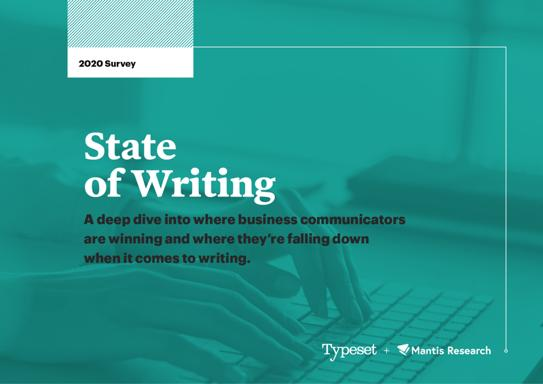Who conducted the research mentioned in the image? The research highlighted in the survey was conducted by Typeset in collaboration with Mantis Research. Together, they aimed to gather actionable data on writing efficacy within the business sector. 